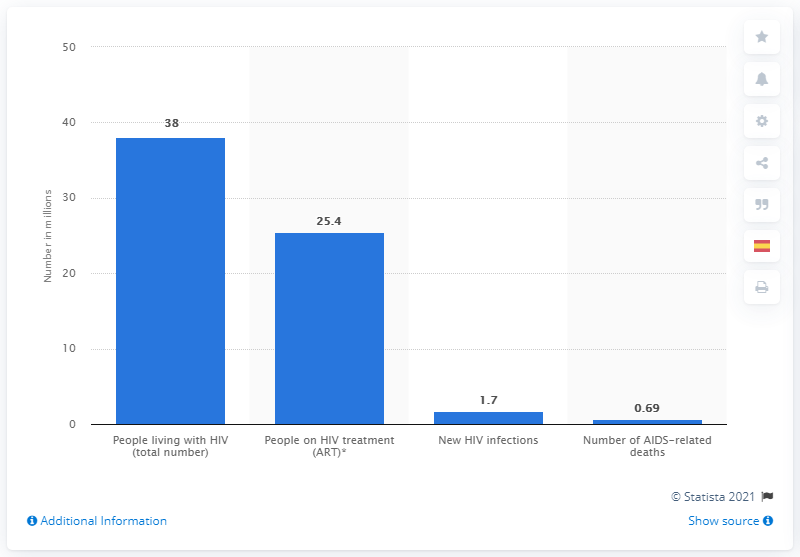Highlight a few significant elements in this photo. An estimated 38 million people were living with HIV/AIDS in 2019. Approximately 25.4 people had access to antiretroviral therapy. 